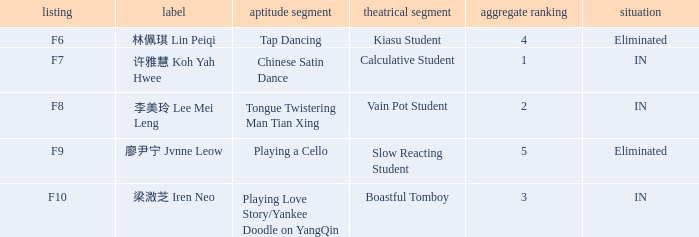What's the acting segment of 林佩琪 lin peiqi's events that are eliminated? Kiasu Student. 